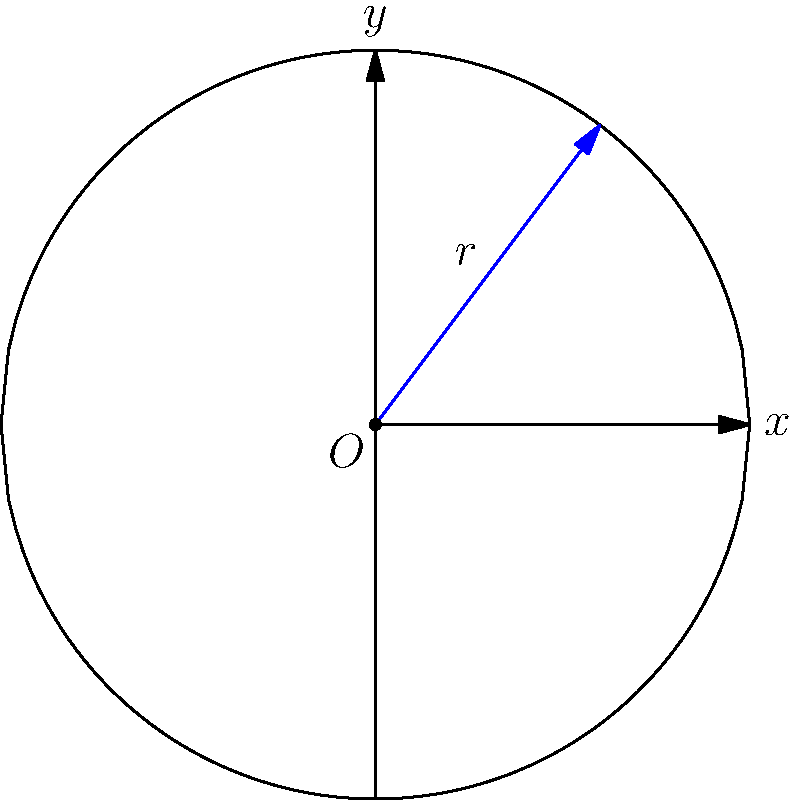Your friend is designing a circular meditation garden with a radius of 10 meters. They want to create a path from the center to the edge that maximizes the area of green space on either side. If the path is represented by the function $y = f(x)$ where $x$ and $y$ are in meters, what is the equation of the optimal path that maximizes the green space? To solve this optimization problem, we'll follow these steps:

1) The area we want to maximize is given by the integral:
   $$A = 2\int_0^{10} \sqrt{100-x^2} - f(x) dx$$

2) This is a variational problem, which can be solved using the Euler-Lagrange equation:
   $$\frac{\partial L}{\partial y} - \frac{d}{dx}\frac{\partial L}{\partial y'} = 0$$
   where $L = \sqrt{100-x^2} - f(x)$

3) In this case, $\frac{\partial L}{\partial y} = -1$ and $\frac{\partial L}{\partial y'} = 0$

4) Substituting into the Euler-Lagrange equation:
   $$-1 - \frac{d}{dx}(0) = 0$$

5) This equation is impossible to satisfy, which means our original assumption of a smooth path is incorrect.

6) The optimal solution is actually a "bang-bang" control, switching between the extreme values.

7) In this case, the optimal path is to go straight up from the center to the circle's edge, then follow the circle's edge to the desired exit point.

8) In polar coordinates, this path can be described as:
   $r = 10$, $\theta = \text{constant}$

9) Converting to Cartesian coordinates:
   $x = 10\cos\theta$
   $y = 10\sin\theta$

10) Solving for y in terms of x:
    $y = \pm\sqrt{100-x^2}$

Therefore, the equation of the optimal path is $y = \sqrt{100-x^2}$ (taking the positive root as we're in the upper half of the circle).
Answer: $y = \sqrt{100-x^2}$ 